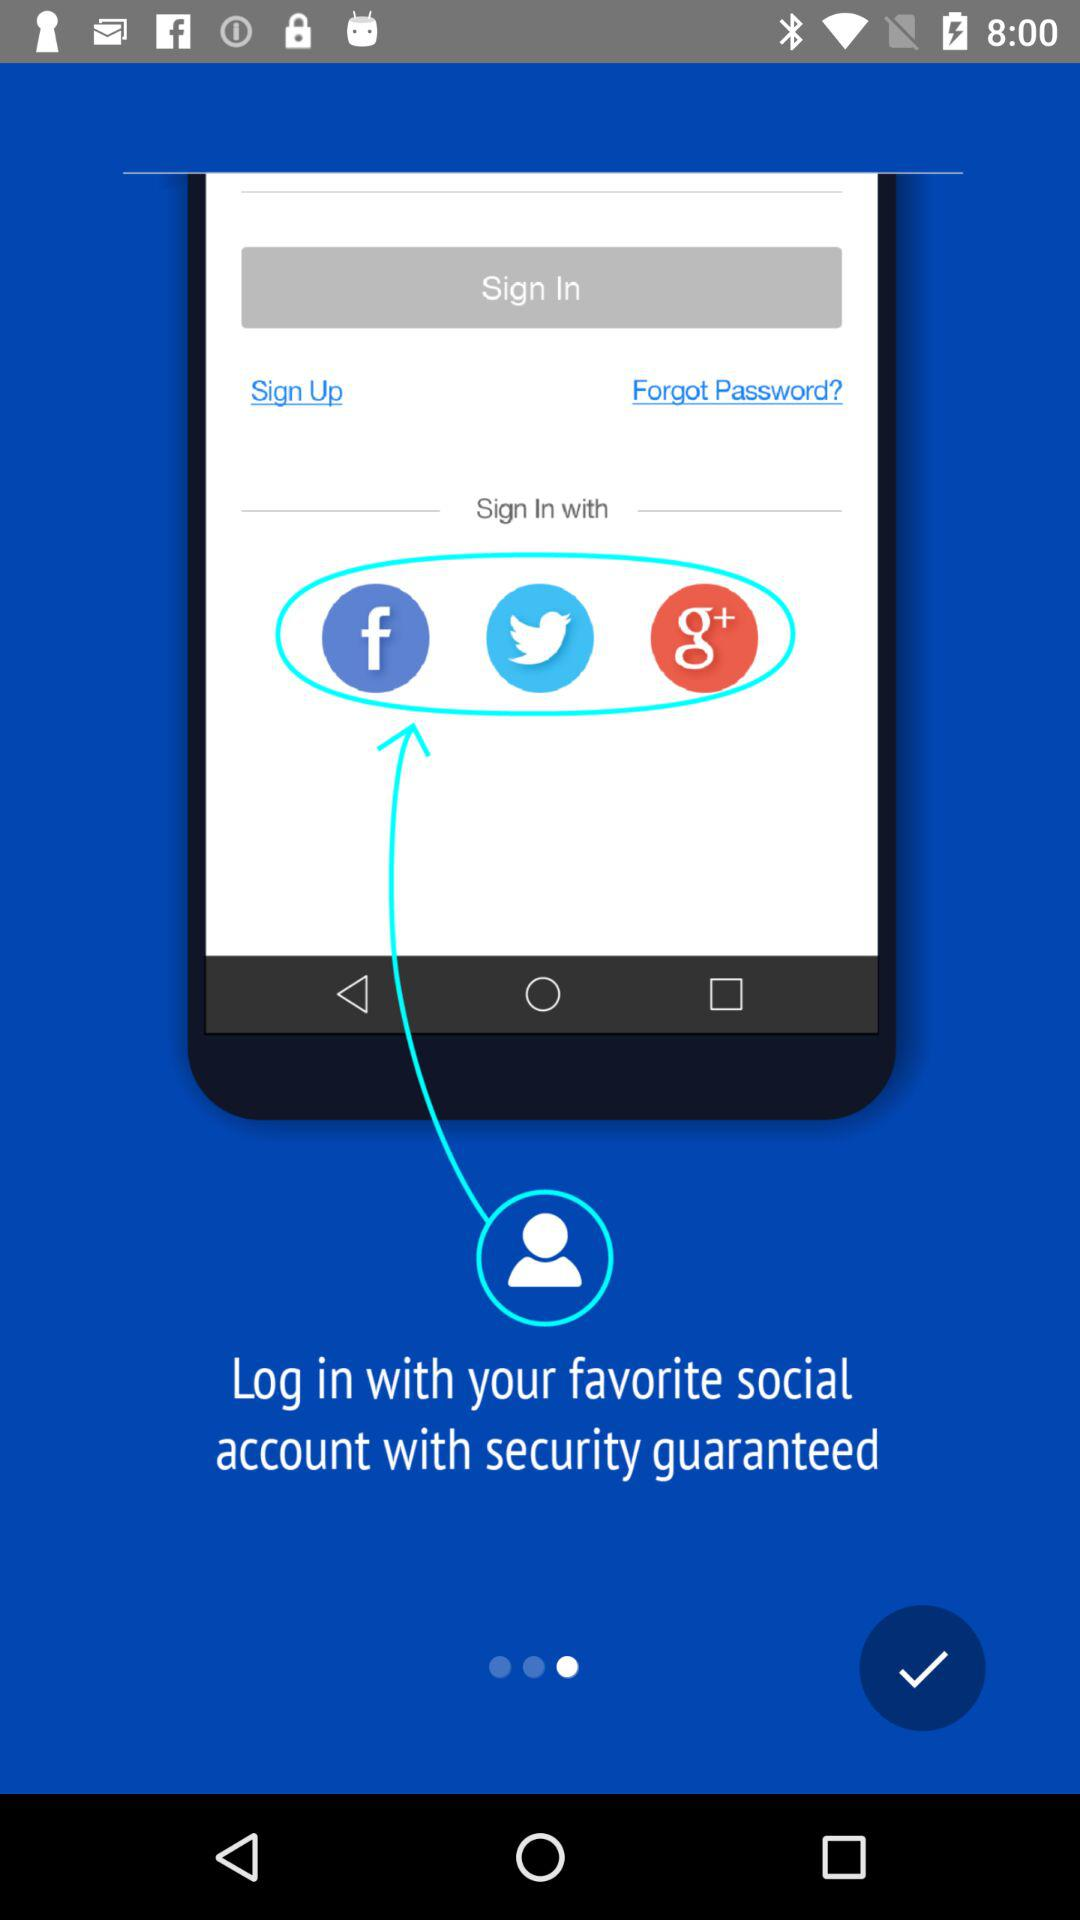What account can be used to sign in? The accounts that can be used to sign in are "Facebook", "Twitter" and "Google+". 